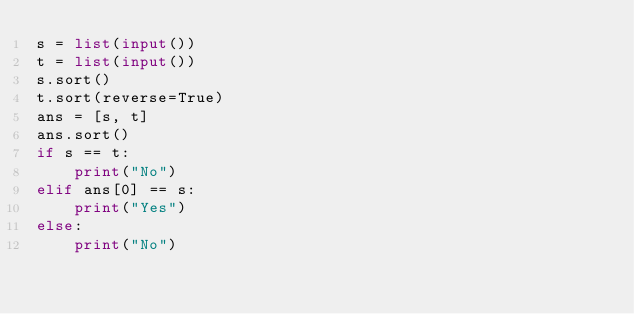<code> <loc_0><loc_0><loc_500><loc_500><_Python_>s = list(input())
t = list(input())
s.sort()
t.sort(reverse=True)
ans = [s, t]
ans.sort()
if s == t:
    print("No")
elif ans[0] == s:
    print("Yes")
else:
    print("No")</code> 